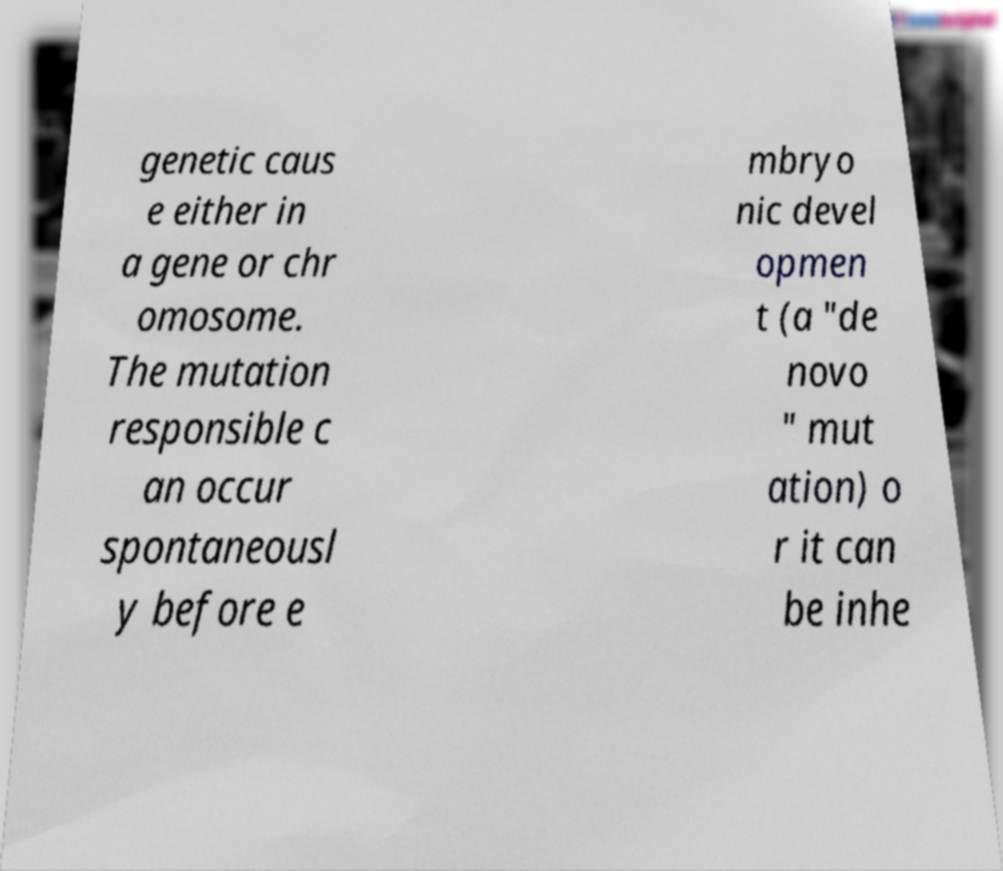Can you accurately transcribe the text from the provided image for me? genetic caus e either in a gene or chr omosome. The mutation responsible c an occur spontaneousl y before e mbryo nic devel opmen t (a "de novo " mut ation) o r it can be inhe 